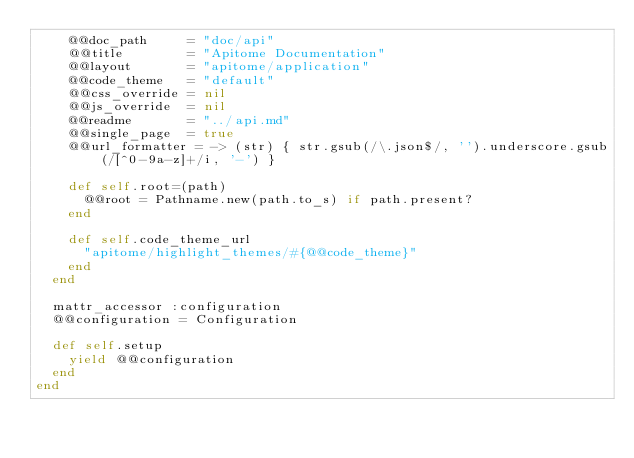Convert code to text. <code><loc_0><loc_0><loc_500><loc_500><_Ruby_>    @@doc_path     = "doc/api"
    @@title        = "Apitome Documentation"
    @@layout       = "apitome/application"
    @@code_theme   = "default"
    @@css_override = nil
    @@js_override  = nil
    @@readme       = "../api.md"
    @@single_page  = true
    @@url_formatter = -> (str) { str.gsub(/\.json$/, '').underscore.gsub(/[^0-9a-z]+/i, '-') }

    def self.root=(path)
      @@root = Pathname.new(path.to_s) if path.present?
    end

    def self.code_theme_url
      "apitome/highlight_themes/#{@@code_theme}"
    end
  end

  mattr_accessor :configuration
  @@configuration = Configuration

  def self.setup
    yield @@configuration
  end
end
</code> 